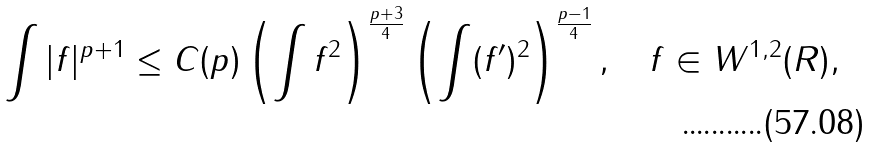Convert formula to latex. <formula><loc_0><loc_0><loc_500><loc_500>\int | f | ^ { p + 1 } \leq C ( p ) \left ( \int f ^ { 2 } \right ) ^ { \frac { p + 3 } 4 } \left ( \int ( f ^ { \prime } ) ^ { 2 } \right ) ^ { \frac { p - 1 } 4 } , \quad f \in W ^ { 1 , 2 } ( { R } ) ,</formula> 